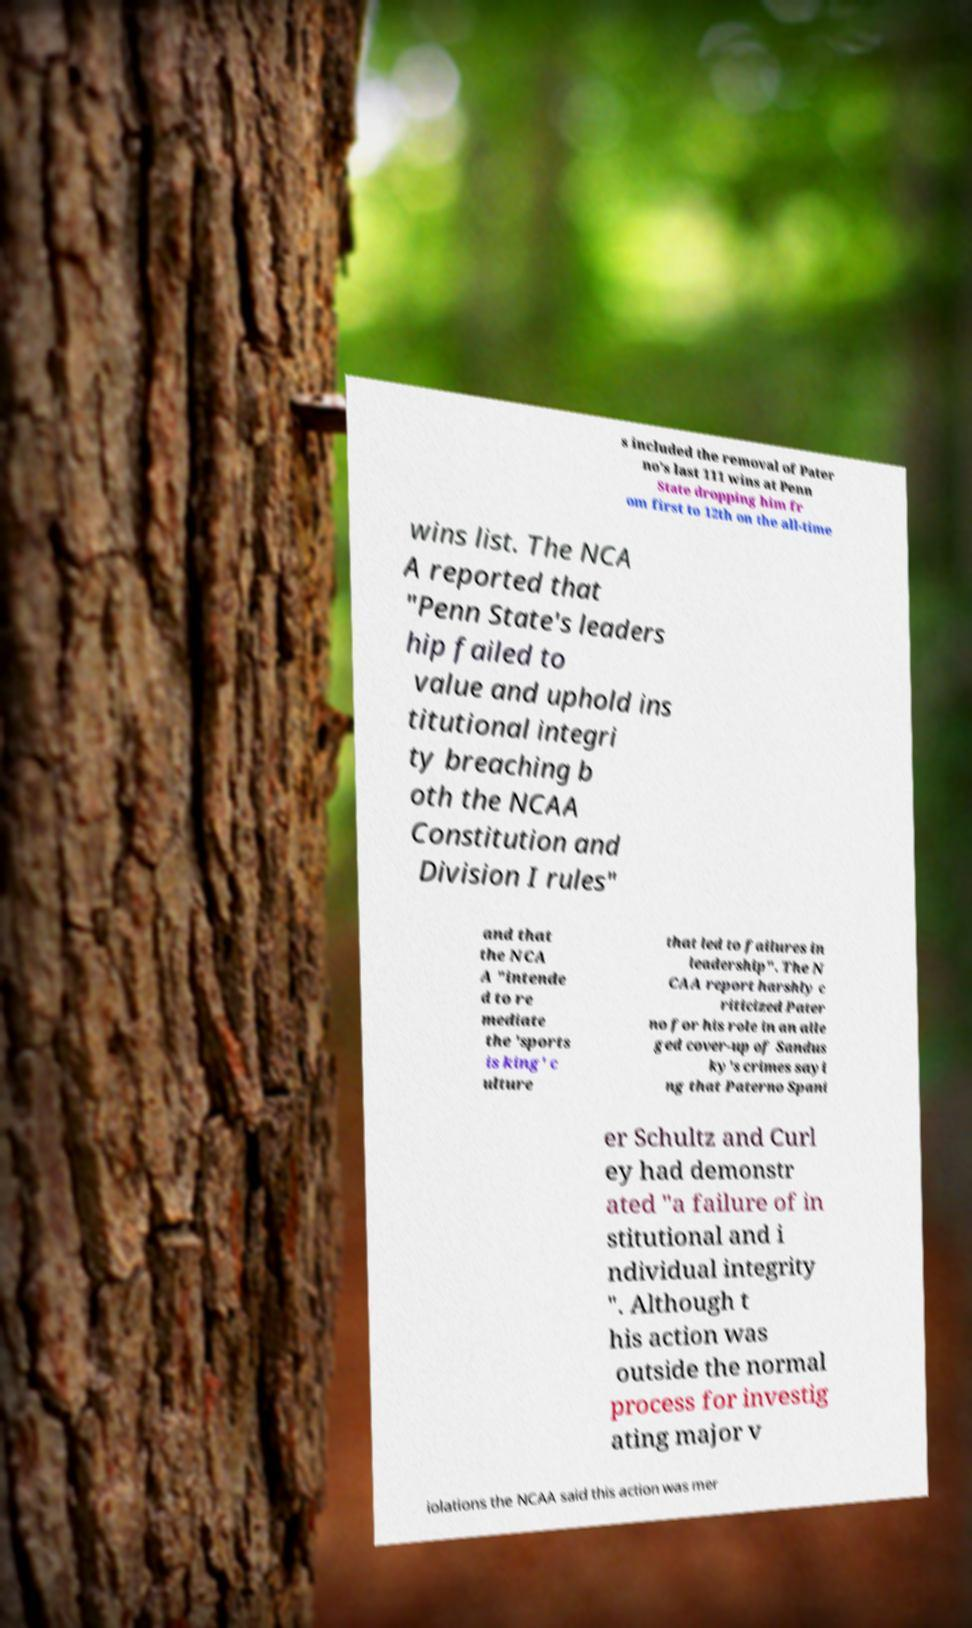For documentation purposes, I need the text within this image transcribed. Could you provide that? s included the removal of Pater no's last 111 wins at Penn State dropping him fr om first to 12th on the all-time wins list. The NCA A reported that "Penn State's leaders hip failed to value and uphold ins titutional integri ty breaching b oth the NCAA Constitution and Division I rules" and that the NCA A "intende d to re mediate the 'sports is king' c ulture that led to failures in leadership". The N CAA report harshly c riticized Pater no for his role in an alle ged cover-up of Sandus ky's crimes sayi ng that Paterno Spani er Schultz and Curl ey had demonstr ated "a failure of in stitutional and i ndividual integrity ". Although t his action was outside the normal process for investig ating major v iolations the NCAA said this action was mer 